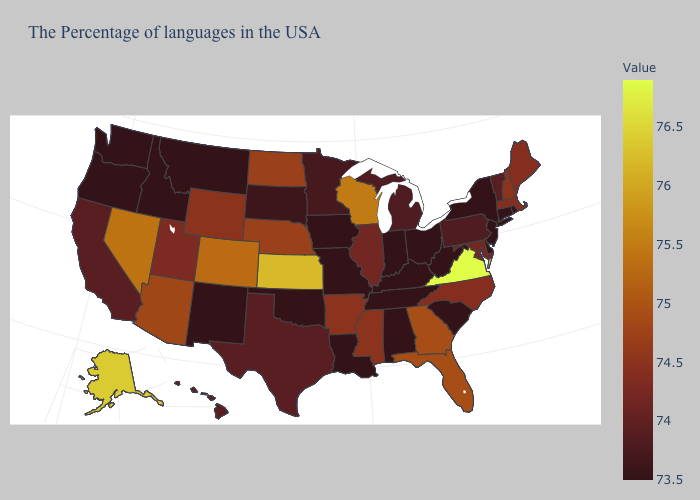Does the map have missing data?
Keep it brief. No. Among the states that border Mississippi , which have the highest value?
Quick response, please. Arkansas. Which states hav the highest value in the MidWest?
Write a very short answer. Kansas. Does Vermont have a lower value than Massachusetts?
Quick response, please. Yes. Is the legend a continuous bar?
Concise answer only. Yes. Which states have the lowest value in the West?
Be succinct. New Mexico, Montana, Idaho, Washington, Oregon. 